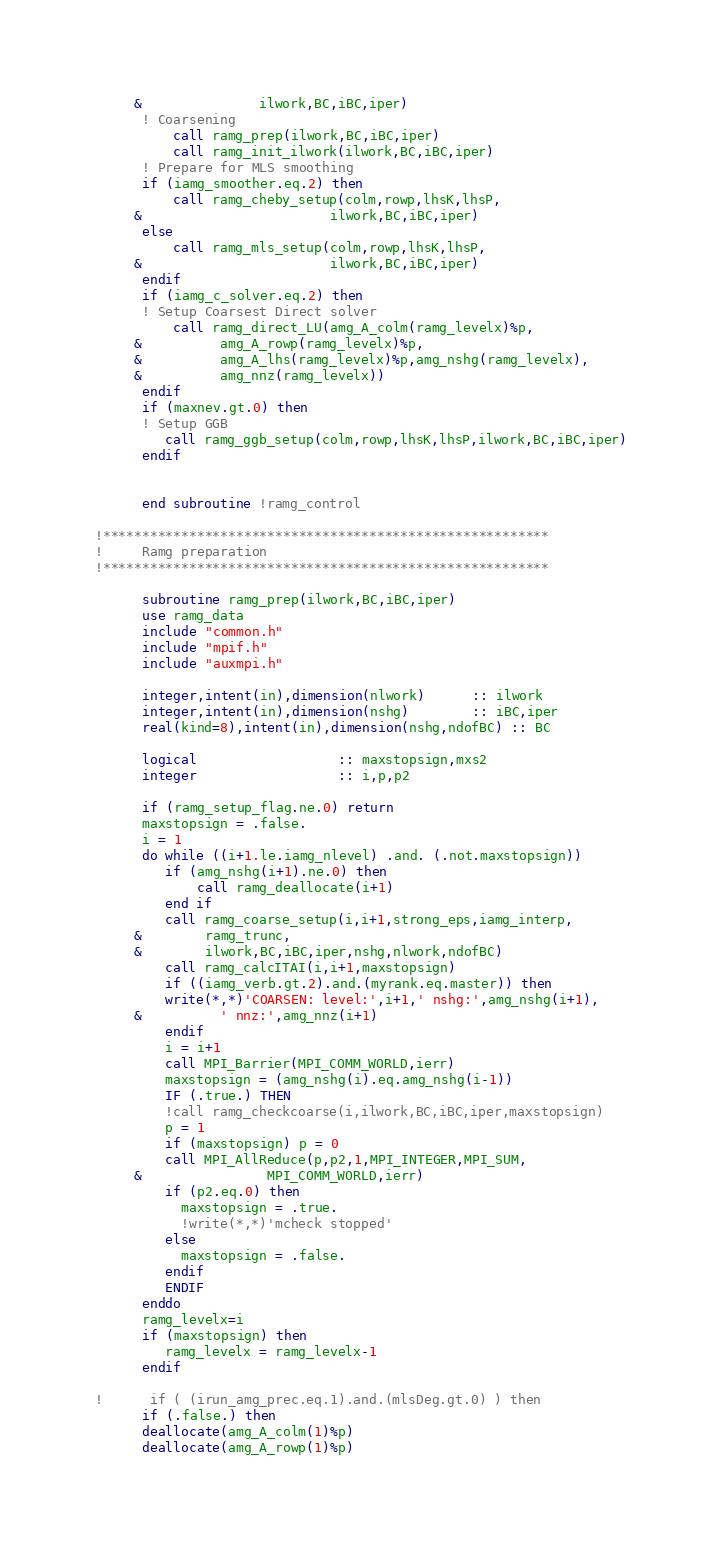Convert code to text. <code><loc_0><loc_0><loc_500><loc_500><_FORTRAN_>     &               ilwork,BC,iBC,iper)
      ! Coarsening
          call ramg_prep(ilwork,BC,iBC,iper)
          call ramg_init_ilwork(ilwork,BC,iBC,iper)
      ! Prepare for MLS smoothing
      if (iamg_smoother.eq.2) then
          call ramg_cheby_setup(colm,rowp,lhsK,lhsP,
     &                        ilwork,BC,iBC,iper)
      else
          call ramg_mls_setup(colm,rowp,lhsK,lhsP,
     &                        ilwork,BC,iBC,iper)
      endif
      if (iamg_c_solver.eq.2) then
      ! Setup Coarsest Direct solver
          call ramg_direct_LU(amg_A_colm(ramg_levelx)%p,
     &          amg_A_rowp(ramg_levelx)%p,
     &          amg_A_lhs(ramg_levelx)%p,amg_nshg(ramg_levelx),
     &          amg_nnz(ramg_levelx))
      endif
      if (maxnev.gt.0) then
      ! Setup GGB
         call ramg_ggb_setup(colm,rowp,lhsK,lhsP,ilwork,BC,iBC,iper)
      endif

     
      end subroutine !ramg_control

!*********************************************************
!     Ramg preparation
!*********************************************************

      subroutine ramg_prep(ilwork,BC,iBC,iper)
      use ramg_data
      include "common.h"
      include "mpif.h"
      include "auxmpi.h"

      integer,intent(in),dimension(nlwork)      :: ilwork
      integer,intent(in),dimension(nshg)        :: iBC,iper
      real(kind=8),intent(in),dimension(nshg,ndofBC) :: BC

      logical                  :: maxstopsign,mxs2
      integer                  :: i,p,p2

      if (ramg_setup_flag.ne.0) return
      maxstopsign = .false.
      i = 1
      do while ((i+1.le.iamg_nlevel) .and. (.not.maxstopsign))
         if (amg_nshg(i+1).ne.0) then
             call ramg_deallocate(i+1)
         end if
         call ramg_coarse_setup(i,i+1,strong_eps,iamg_interp,
     &        ramg_trunc,
     &        ilwork,BC,iBC,iper,nshg,nlwork,ndofBC)
         call ramg_calcITAI(i,i+1,maxstopsign)
         if ((iamg_verb.gt.2).and.(myrank.eq.master)) then
         write(*,*)'COARSEN: level:',i+1,' nshg:',amg_nshg(i+1),
     &          ' nnz:',amg_nnz(i+1)
         endif
         i = i+1
         call MPI_Barrier(MPI_COMM_WORLD,ierr)
         maxstopsign = (amg_nshg(i).eq.amg_nshg(i-1)) 
         IF (.true.) THEN
         !call ramg_checkcoarse(i,ilwork,BC,iBC,iper,maxstopsign)
         p = 1
         if (maxstopsign) p = 0
         call MPI_AllReduce(p,p2,1,MPI_INTEGER,MPI_SUM,
     &                MPI_COMM_WORLD,ierr)
         if (p2.eq.0) then
           maxstopsign = .true.
           !write(*,*)'mcheck stopped'
         else
           maxstopsign = .false.
         endif
         ENDIF
      enddo
      ramg_levelx=i
      if (maxstopsign) then 
         ramg_levelx = ramg_levelx-1
      endif

!      if ( (irun_amg_prec.eq.1).and.(mlsDeg.gt.0) ) then
      if (.false.) then
      deallocate(amg_A_colm(1)%p)
      deallocate(amg_A_rowp(1)%p)</code> 